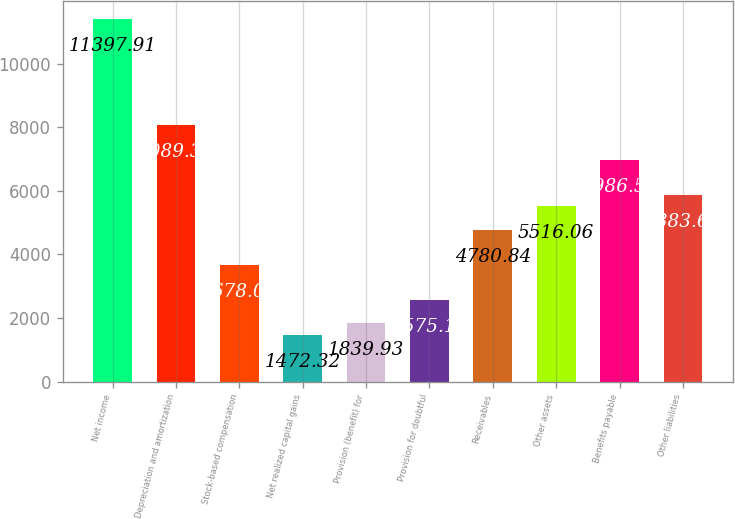Convert chart to OTSL. <chart><loc_0><loc_0><loc_500><loc_500><bar_chart><fcel>Net income<fcel>Depreciation and amortization<fcel>Stock-based compensation<fcel>Net realized capital gains<fcel>Provision (benefit) for<fcel>Provision for doubtful<fcel>Receivables<fcel>Other assets<fcel>Benefits payable<fcel>Other liabilities<nl><fcel>11397.9<fcel>8089.38<fcel>3678.01<fcel>1472.32<fcel>1839.93<fcel>2575.16<fcel>4780.84<fcel>5516.06<fcel>6986.52<fcel>5883.68<nl></chart> 